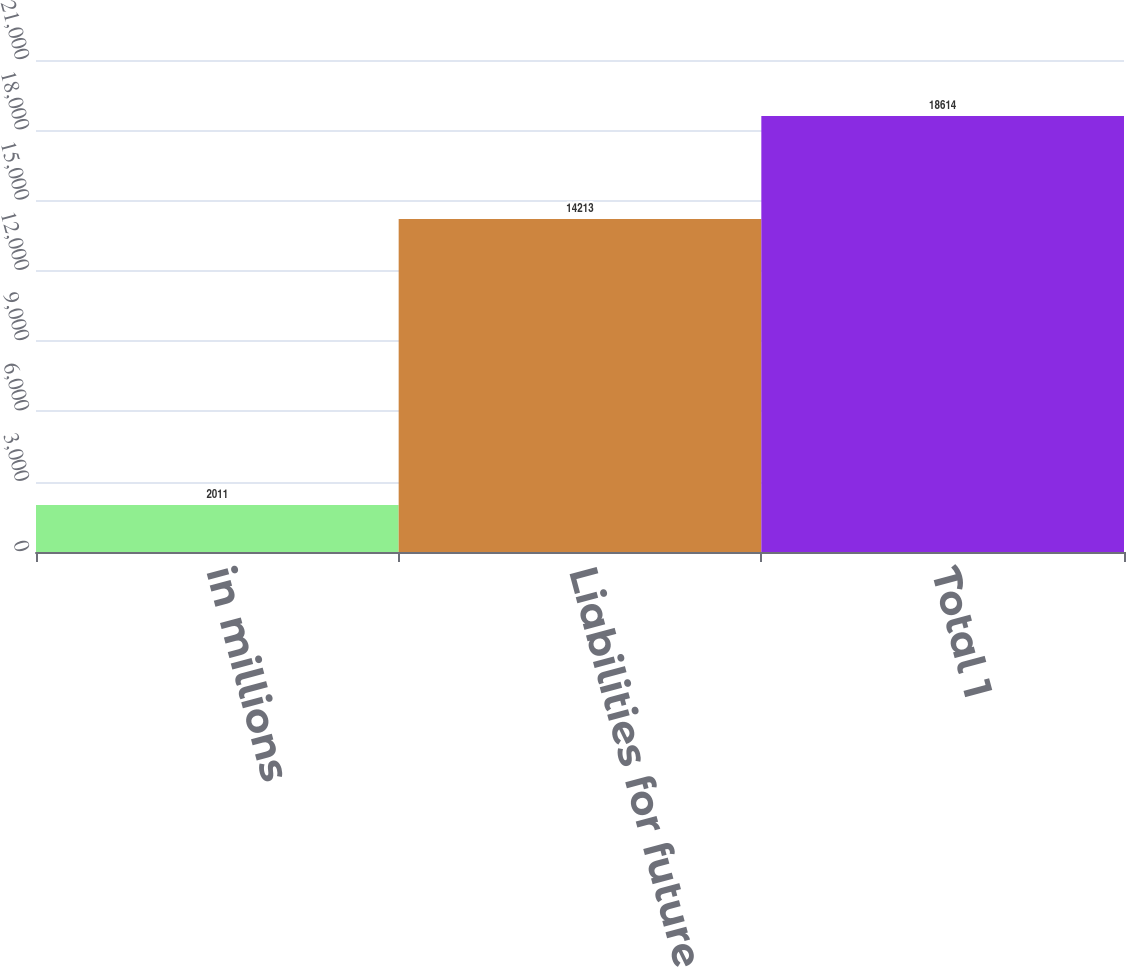Convert chart. <chart><loc_0><loc_0><loc_500><loc_500><bar_chart><fcel>in millions<fcel>Liabilities for future<fcel>Total 1<nl><fcel>2011<fcel>14213<fcel>18614<nl></chart> 